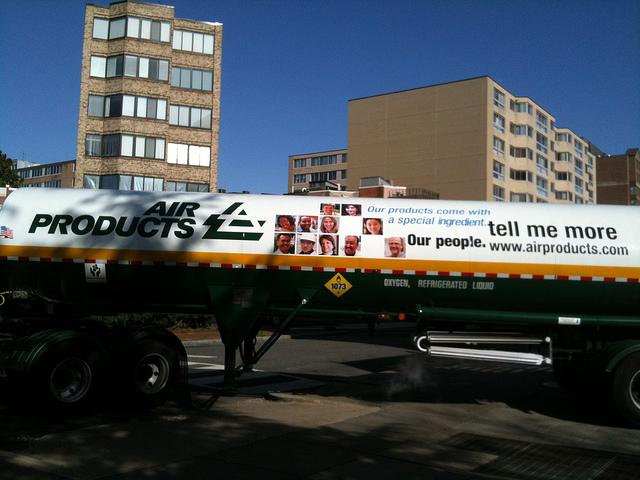What is the company being advertise on the truck?
Answer briefly. Air products. What sign is on the track?
Concise answer only. Air products. Where is the truck parked?
Give a very brief answer. Parking lot. 